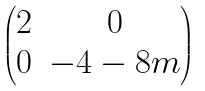Convert formula to latex. <formula><loc_0><loc_0><loc_500><loc_500>\begin{pmatrix} 2 & 0 \\ 0 & - 4 - 8 m \end{pmatrix}</formula> 